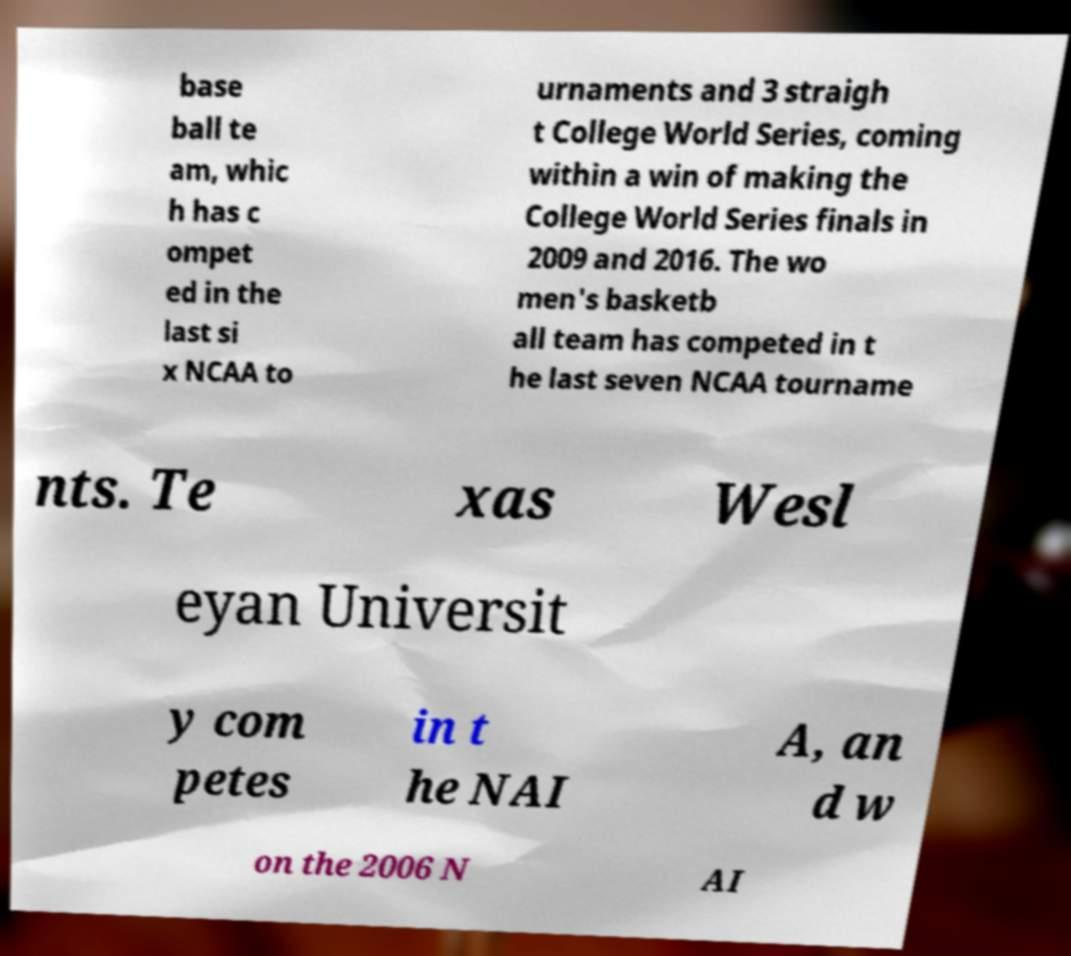For documentation purposes, I need the text within this image transcribed. Could you provide that? base ball te am, whic h has c ompet ed in the last si x NCAA to urnaments and 3 straigh t College World Series, coming within a win of making the College World Series finals in 2009 and 2016. The wo men's basketb all team has competed in t he last seven NCAA tourname nts. Te xas Wesl eyan Universit y com petes in t he NAI A, an d w on the 2006 N AI 